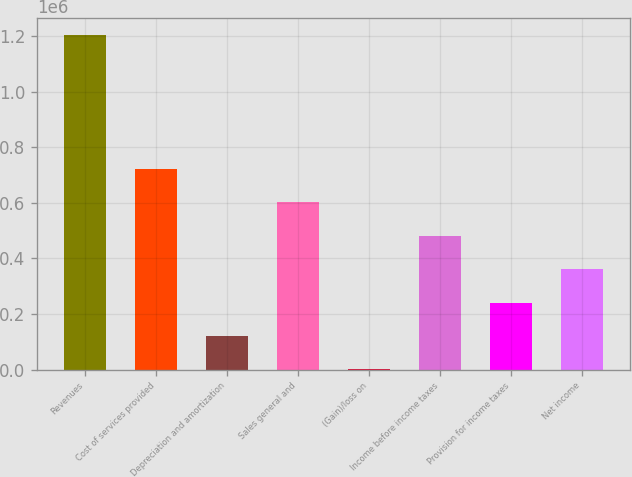Convert chart to OTSL. <chart><loc_0><loc_0><loc_500><loc_500><bar_chart><fcel>Revenues<fcel>Cost of services provided<fcel>Depreciation and amortization<fcel>Sales general and<fcel>(Gain)/loss on<fcel>Income before income taxes<fcel>Provision for income taxes<fcel>Net income<nl><fcel>1.20506e+06<fcel>723200<fcel>120871<fcel>602734<fcel>405<fcel>482269<fcel>241337<fcel>361803<nl></chart> 